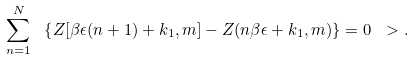Convert formula to latex. <formula><loc_0><loc_0><loc_500><loc_500>\sum _ { n = 1 } ^ { N } \ \left \{ Z [ \beta \epsilon ( n + 1 ) + k _ { 1 } , m ] - Z ( n \beta \epsilon + k _ { 1 } , m ) \right \} = 0 \ > .</formula> 